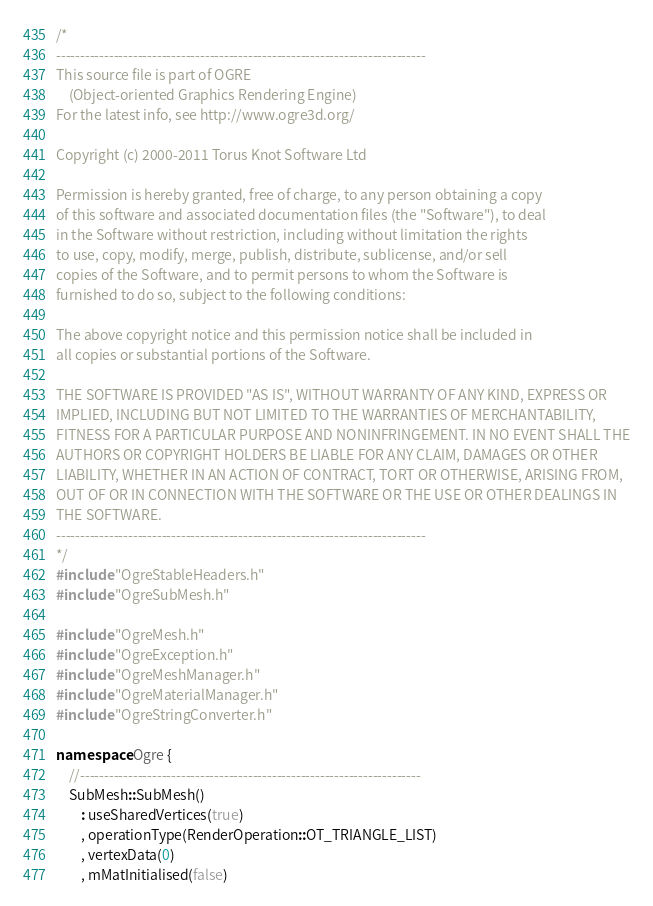Convert code to text. <code><loc_0><loc_0><loc_500><loc_500><_C++_>/*
-----------------------------------------------------------------------------
This source file is part of OGRE
    (Object-oriented Graphics Rendering Engine)
For the latest info, see http://www.ogre3d.org/

Copyright (c) 2000-2011 Torus Knot Software Ltd

Permission is hereby granted, free of charge, to any person obtaining a copy
of this software and associated documentation files (the "Software"), to deal
in the Software without restriction, including without limitation the rights
to use, copy, modify, merge, publish, distribute, sublicense, and/or sell
copies of the Software, and to permit persons to whom the Software is
furnished to do so, subject to the following conditions:

The above copyright notice and this permission notice shall be included in
all copies or substantial portions of the Software.

THE SOFTWARE IS PROVIDED "AS IS", WITHOUT WARRANTY OF ANY KIND, EXPRESS OR
IMPLIED, INCLUDING BUT NOT LIMITED TO THE WARRANTIES OF MERCHANTABILITY,
FITNESS FOR A PARTICULAR PURPOSE AND NONINFRINGEMENT. IN NO EVENT SHALL THE
AUTHORS OR COPYRIGHT HOLDERS BE LIABLE FOR ANY CLAIM, DAMAGES OR OTHER
LIABILITY, WHETHER IN AN ACTION OF CONTRACT, TORT OR OTHERWISE, ARISING FROM,
OUT OF OR IN CONNECTION WITH THE SOFTWARE OR THE USE OR OTHER DEALINGS IN
THE SOFTWARE.
-----------------------------------------------------------------------------
*/
#include "OgreStableHeaders.h"
#include "OgreSubMesh.h"

#include "OgreMesh.h"
#include "OgreException.h"
#include "OgreMeshManager.h"
#include "OgreMaterialManager.h"
#include "OgreStringConverter.h"

namespace Ogre {
    //-----------------------------------------------------------------------
    SubMesh::SubMesh()
        : useSharedVertices(true)
        , operationType(RenderOperation::OT_TRIANGLE_LIST)
        , vertexData(0)
        , mMatInitialised(false)</code> 